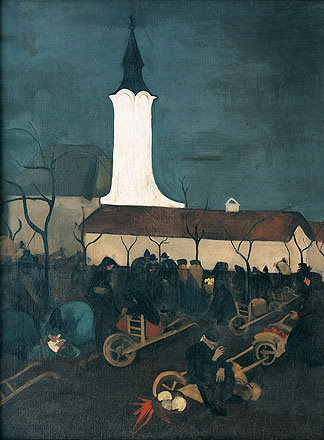How does the painting reflect elements of the post-impressionist movement? This painting reflects post-impressionist elements through its use of a dark, moody color scheme that conveys emotion and atmosphere over precise realism. The loose, expressive brushstrokes enhance the textural quality of the scene, lending a dynamic, almost turbulent feel to the motion around the church. Such a style emphasizes the artist's personal expression and the emotional undercurrents of the depicted scene. Can you point out specific elements in the artwork that highlight these post-impressionist features? The brushwork in the trees and the sky, which avoids detailed depiction in favor of broad, swirling strokes, highlights the post-impressionist feature of capturing feeling over form. Additionally, the contrast between the illuminated steeple and the dark, indistinct figures on the ground further underscores the emotional dichotomy of solace and somberness, characteristic of post-impressionism's intent to evoke rather than describe. 